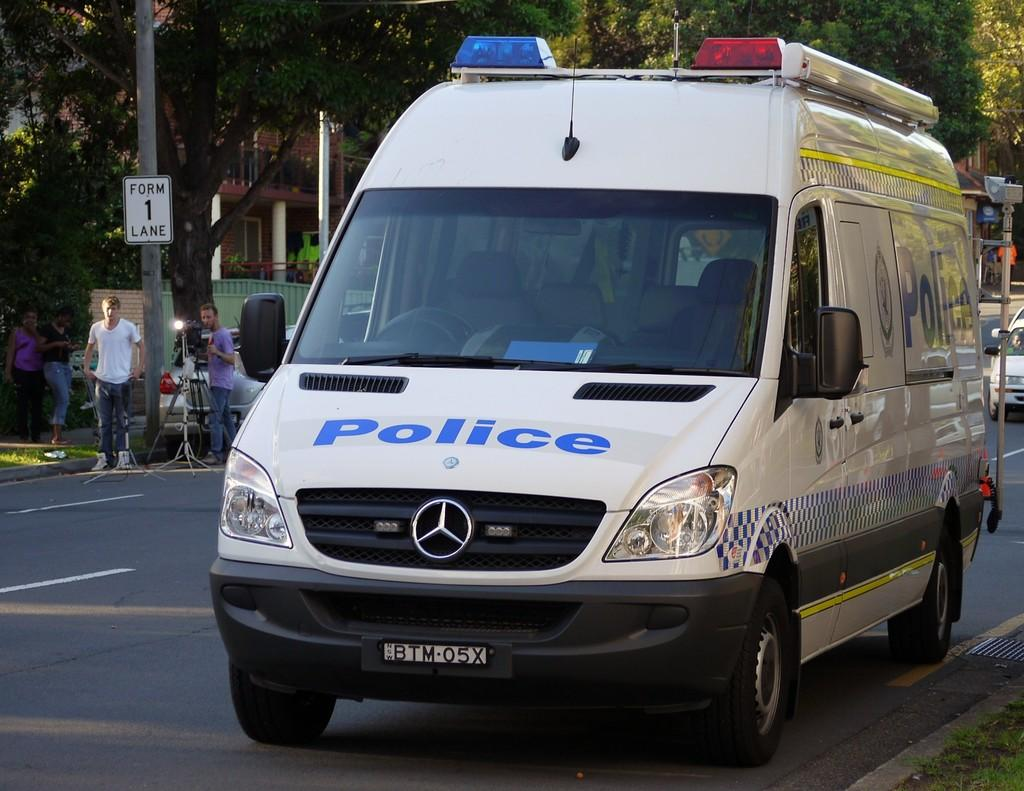<image>
Share a concise interpretation of the image provided. a Police van parked along the side of a street 